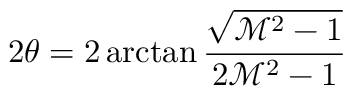<formula> <loc_0><loc_0><loc_500><loc_500>2 \theta = 2 \arctan \frac { \sqrt { \mathcal { M } ^ { 2 } - 1 } } { 2 \mathcal { M } ^ { 2 } - 1 }</formula> 